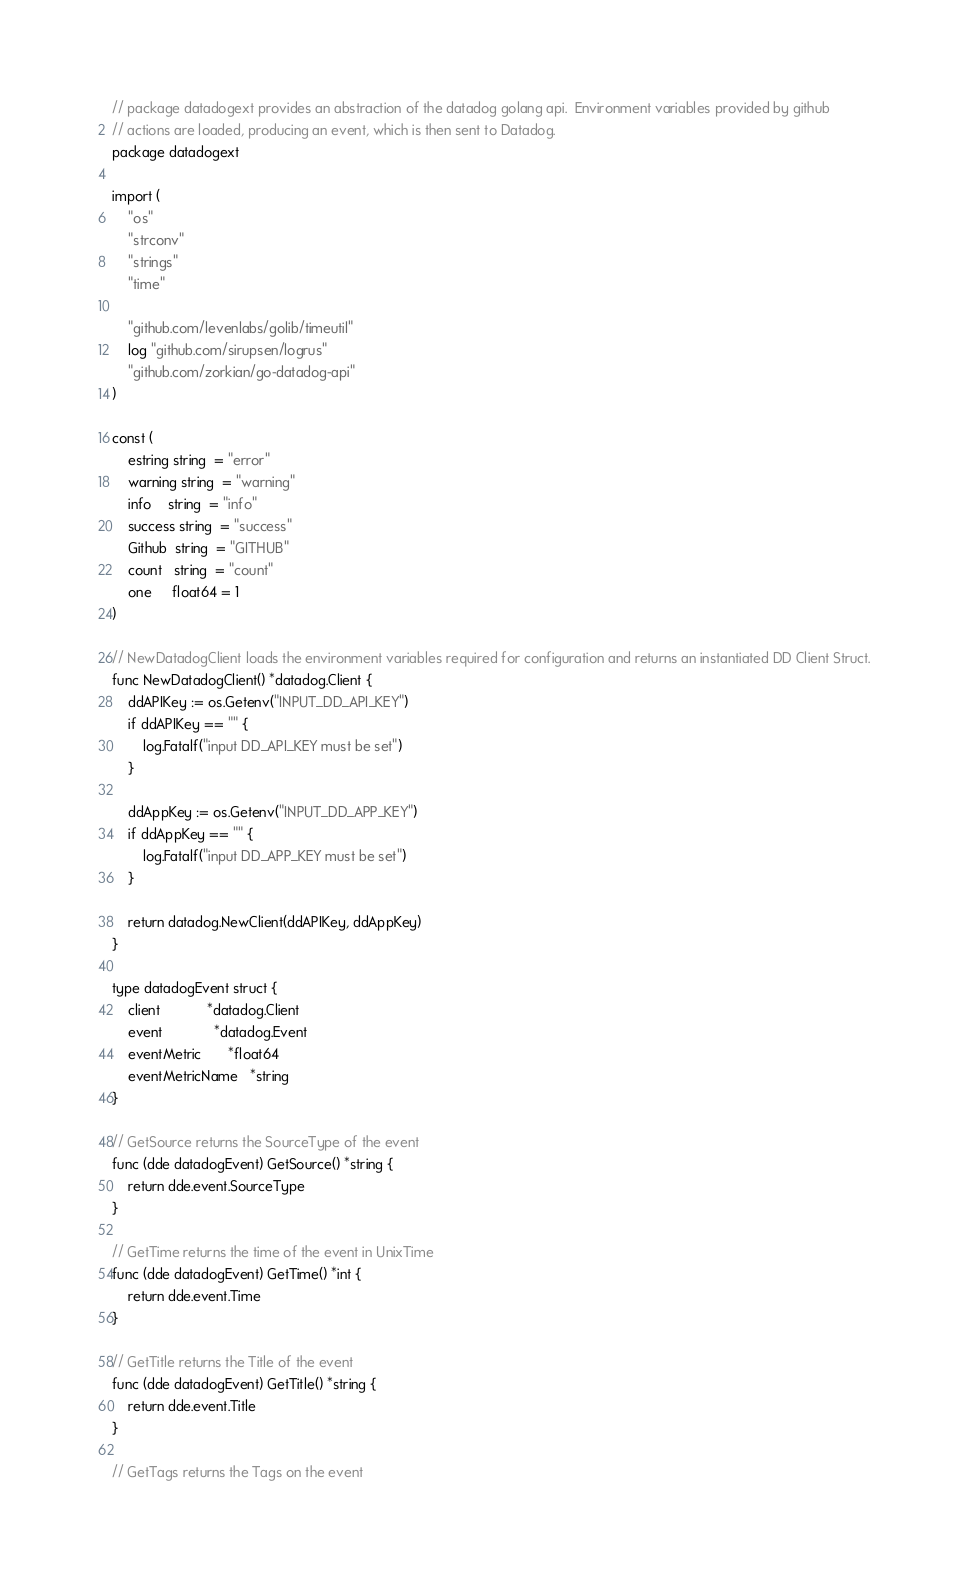<code> <loc_0><loc_0><loc_500><loc_500><_Go_>// package datadogext provides an abstraction of the datadog golang api.  Environment variables provided by github
// actions are loaded, producing an event, which is then sent to Datadog.
package datadogext

import (
	"os"
	"strconv"
	"strings"
	"time"

	"github.com/levenlabs/golib/timeutil"
	log "github.com/sirupsen/logrus"
	"github.com/zorkian/go-datadog-api"
)

const (
	estring string  = "error"
	warning string  = "warning"
	info    string  = "info"
	success string  = "success"
	Github  string  = "GITHUB"
	count   string  = "count"
	one     float64 = 1
)

// NewDatadogClient loads the environment variables required for configuration and returns an instantiated DD Client Struct.
func NewDatadogClient() *datadog.Client {
	ddAPIKey := os.Getenv("INPUT_DD_API_KEY")
	if ddAPIKey == "" {
		log.Fatalf("input DD_API_KEY must be set")
	}

	ddAppKey := os.Getenv("INPUT_DD_APP_KEY")
	if ddAppKey == "" {
		log.Fatalf("input DD_APP_KEY must be set")
	}

	return datadog.NewClient(ddAPIKey, ddAppKey)
}

type datadogEvent struct {
	client            *datadog.Client
	event             *datadog.Event
	eventMetric       *float64
	eventMetricName   *string
}

// GetSource returns the SourceType of the event
func (dde datadogEvent) GetSource() *string {
	return dde.event.SourceType
}

// GetTime returns the time of the event in UnixTime
func (dde datadogEvent) GetTime() *int {
	return dde.event.Time
}

// GetTitle returns the Title of the event
func (dde datadogEvent) GetTitle() *string {
	return dde.event.Title
}

// GetTags returns the Tags on the event</code> 